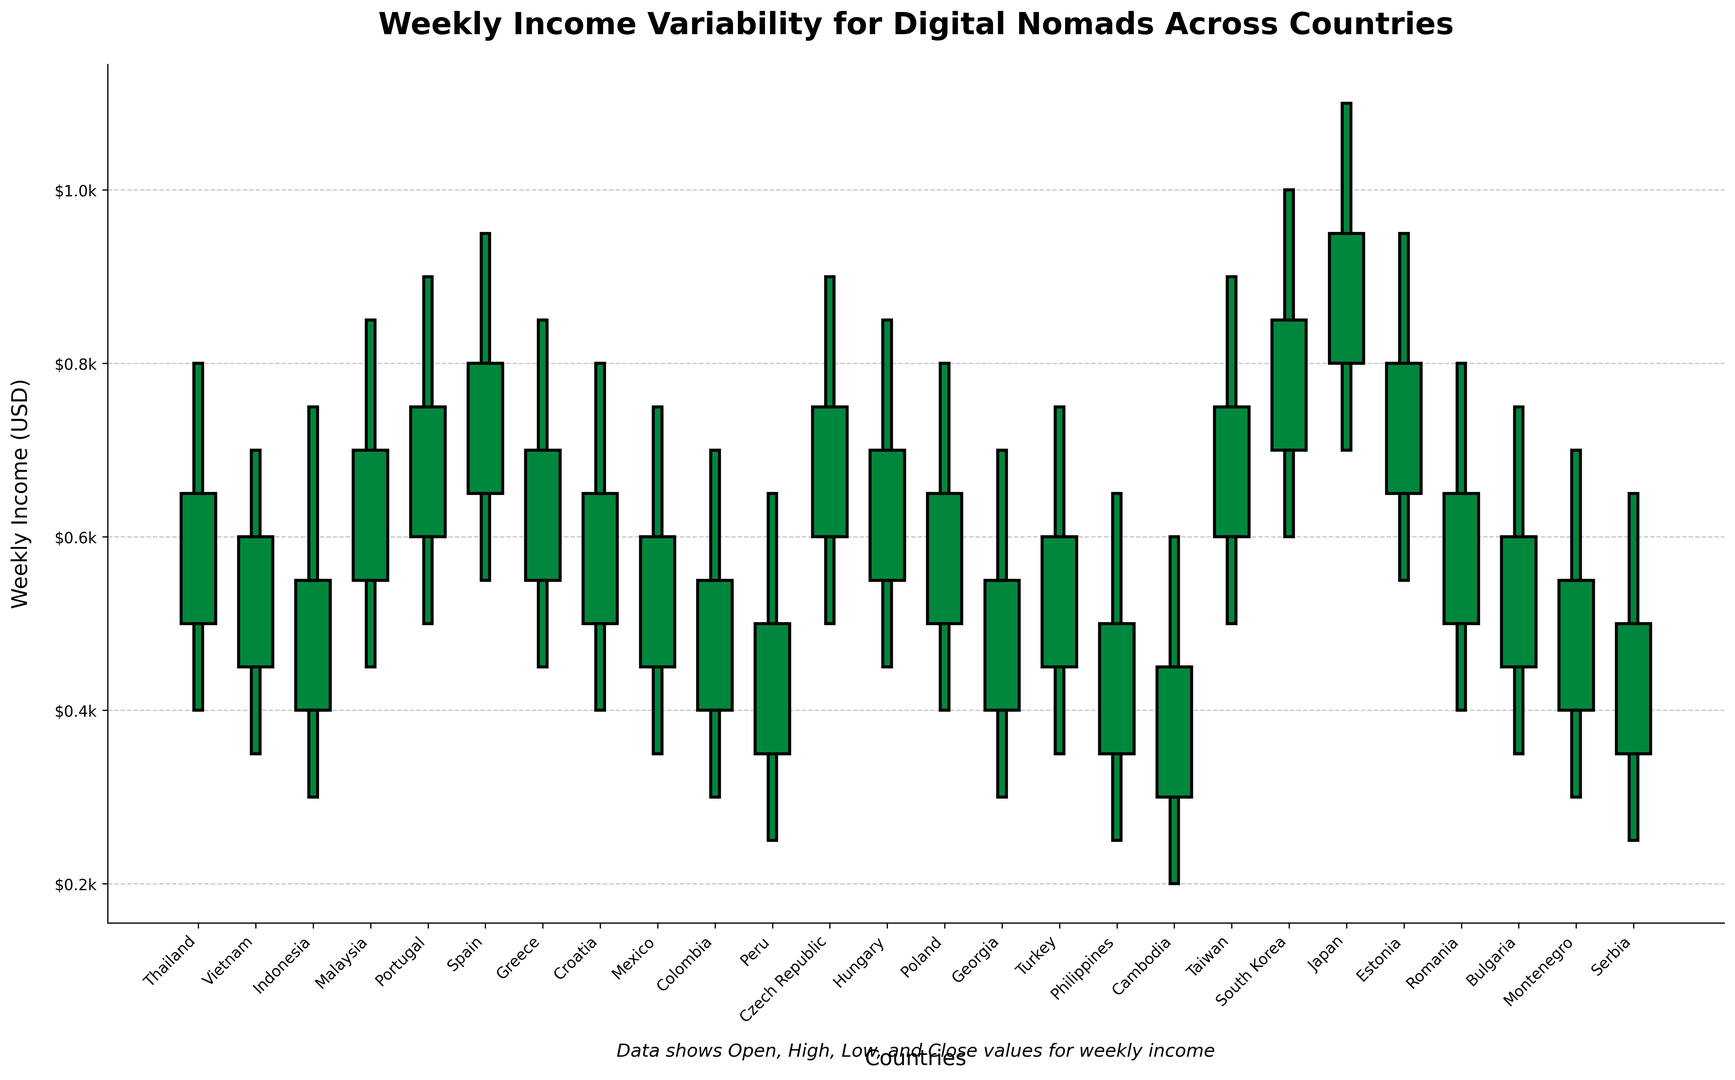What country has the highest weekly income variability? By looking at the chart, find the country with the largest difference between the high and low values for weekly income. Japan has the largest spread between its highest ($1100) and lowest ($700) weekly income values, resulting in a range of $400.
Answer: Japan Which countries had a positive change in weekly income from open to close? Identify countries where the close value (weekly income at the end) is higher than the open value (weekly income at the start), indicated by green bars. Thailand, Vietnam, Malaysia, Portugal, Spain, Greece, Croatia, Czech Republic, Hungary, Poland, Taiwan, South Korea, Japan, and Estonia show positive changes.
Answer: Thailand, Vietnam, Malaysia, Portugal, Spain, Greece, Croatia, Czech Republic, Hungary, Poland, Taiwan, South Korea, Japan, Estonia How does the weekly income in the Philippines compare to that in Thailand? Compare the open, high, low, and close values for the Philippines and Thailand. Thailand has an open (500), high (800), low (400), and close (650), whereas the Philippines has an open (350), high (650), low (250), and close (500).
Answer: Thailand has higher income values than the Philippines What is the average weekly income in South Korea at the open and close points? Add the open and close values for South Korea and then divide by 2. Open is $700, close is $850, so (700 + 850)/2 = $775.
Answer: $775 Which country had the smallest weekly income range? Find the smallest difference between the high and low values. Cambodia had high ($600) and low ($200) weekly income values, with a range of $400 - $200 = $200.
Answer: Cambodia Does Mexico or Colombia have a higher weekly income high point? Compare the high values of Mexico and Colombia. Mexico's high is $750, while Colombia's high is $700.
Answer: Mexico What is the weekly loss or gain in income for Romania? Compute the difference between the close and open values. For Romania, the open is $500 and the close is $650, resulting in a gain of $650 - $500 = $150.
Answer: Gain of $150 Which countries showed a negative change (loss) in weekly income? Identify countries where the close value is lower than the open value, indicated by red bars. Indonesia, Mexico, Colombia, Peru, Georgia, Turkey, Philippines, Cambodia, Romania, Bulgaria, Montenegro, and Serbia show a decrease.
Answer: Indonesia, Mexico, Colombia, Peru, Georgia, Turkey, Philippines, Cambodia, Romania, Bulgaria, Montenegro, Serbia What is the difference in the weekly income high points between Japan and Taiwan? Subtract the high value of Taiwan from the high value of Japan. Japan's high is $1100, and Taiwan's high is $900, so $1100 - $900 = $200.
Answer: $200 In which country is the weekly income lowest at the closing point? Find the country with the smallest closing value from the chart. Cambodia has the lowest closing value at $450.
Answer: Cambodia 